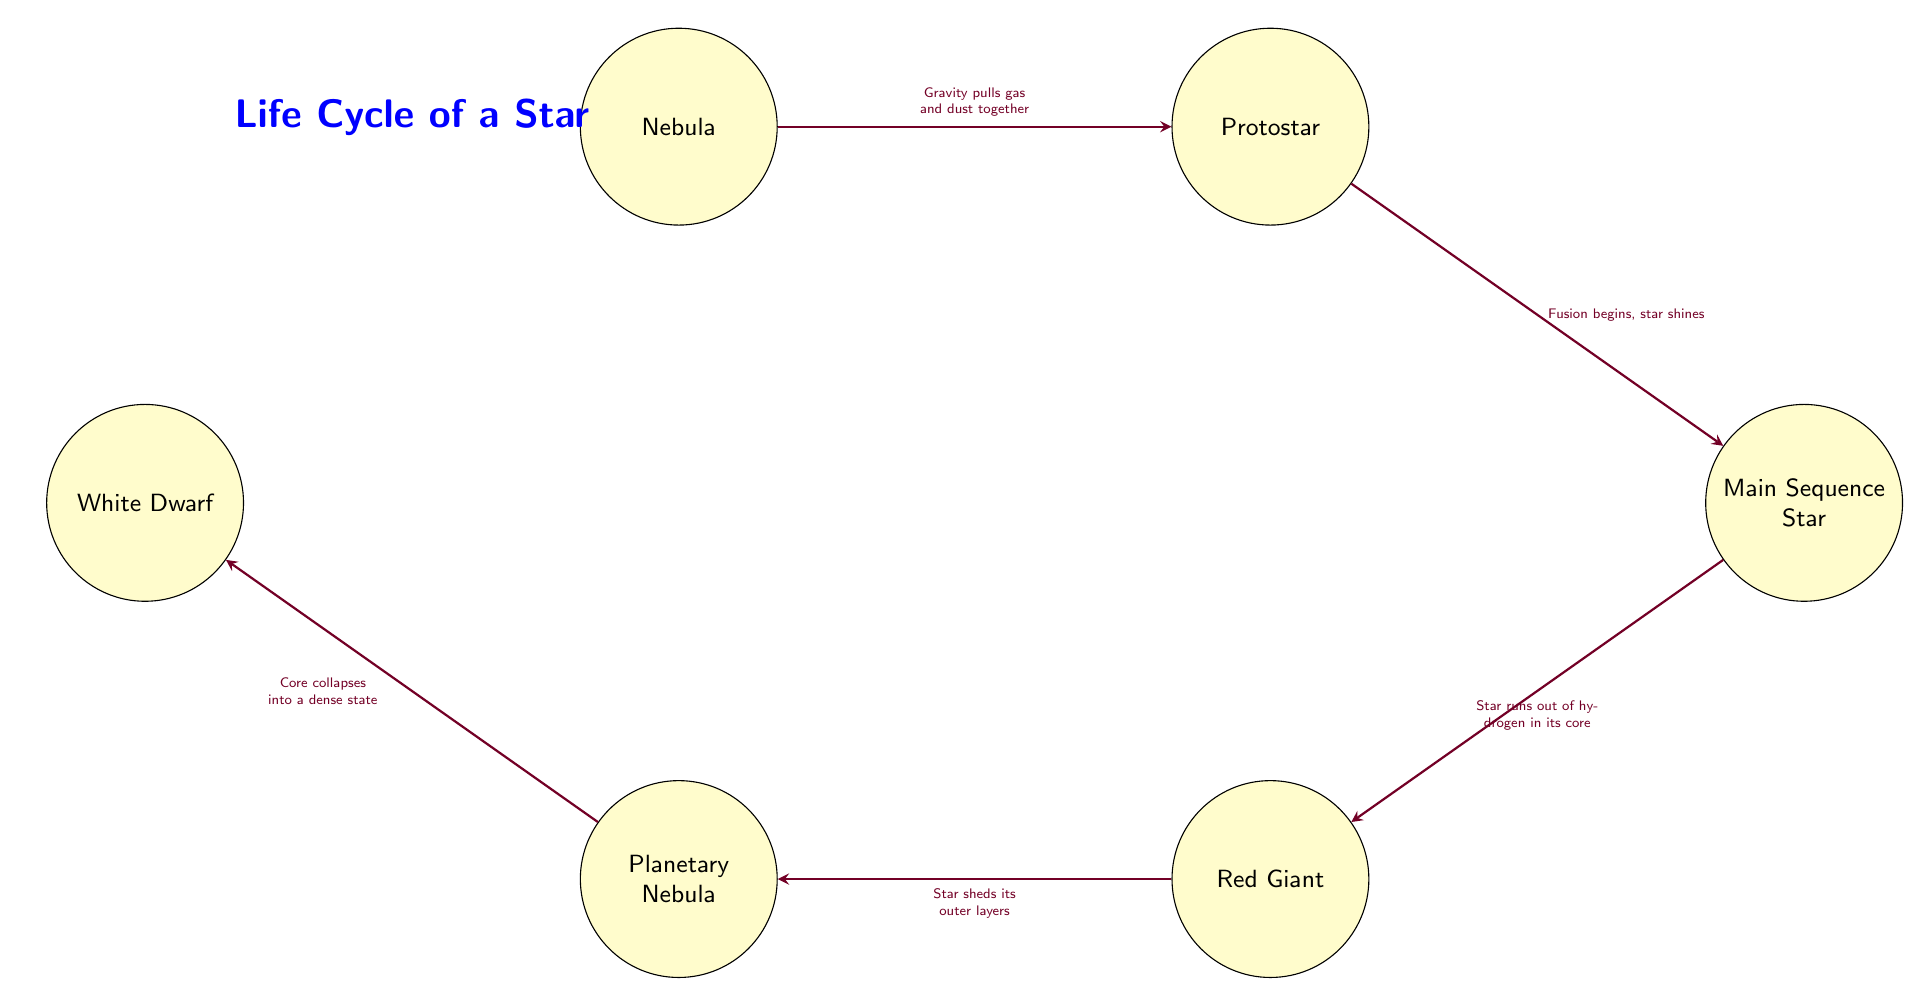What is the first stage in the life cycle of a star? The diagram starts with the node labeled "Nebula," which is the first stage where stars are formed.
Answer: Nebula How many nodes are present in the diagram? There are six nodes in total: Nebula, Protostar, Main Sequence Star, Red Giant, Planetary Nebula, and White Dwarf.
Answer: 6 Which node comes after the Main Sequence Star? According to the diagram, the node directly following the "Main Sequence Star" is the "Red Giant."
Answer: Red Giant What happens to a star when it runs out of hydrogen in its core? The flow indicates that when a star runs out of hydrogen in its core, it transitions to the "Red Giant" stage.
Answer: Red Giant What is the final stage of a star's life cycle according to the flow chart? The last node in the flow diagram is "White Dwarf," which represents the final stage of a star's life cycle.
Answer: White Dwarf What causes the Protostar to form? The diagram specifies that "Gravity pulls gas and dust together" to form a protostar from the nebula.
Answer: Gravity pulls gas and dust together What is the outcome after the Red Giant sheds its outer layers? The subsequent stage after a star sheds its outer layers (from the Red Giant stage) is the "Planetary Nebula," as shown in the diagram.
Answer: Planetary Nebula How does a Protostar become a Main Sequence Star? The flow from "Protostar" to "Main Sequence Star" is marked by "Fusion begins, star shines," indicating this transformation.
Answer: Fusion begins, star shines What is the significance of the arrows in the flow chart? The arrows illustrate the direction of progression through the stages of a star's life cycle, showing how one stage leads to the next.
Answer: Direction of progression 